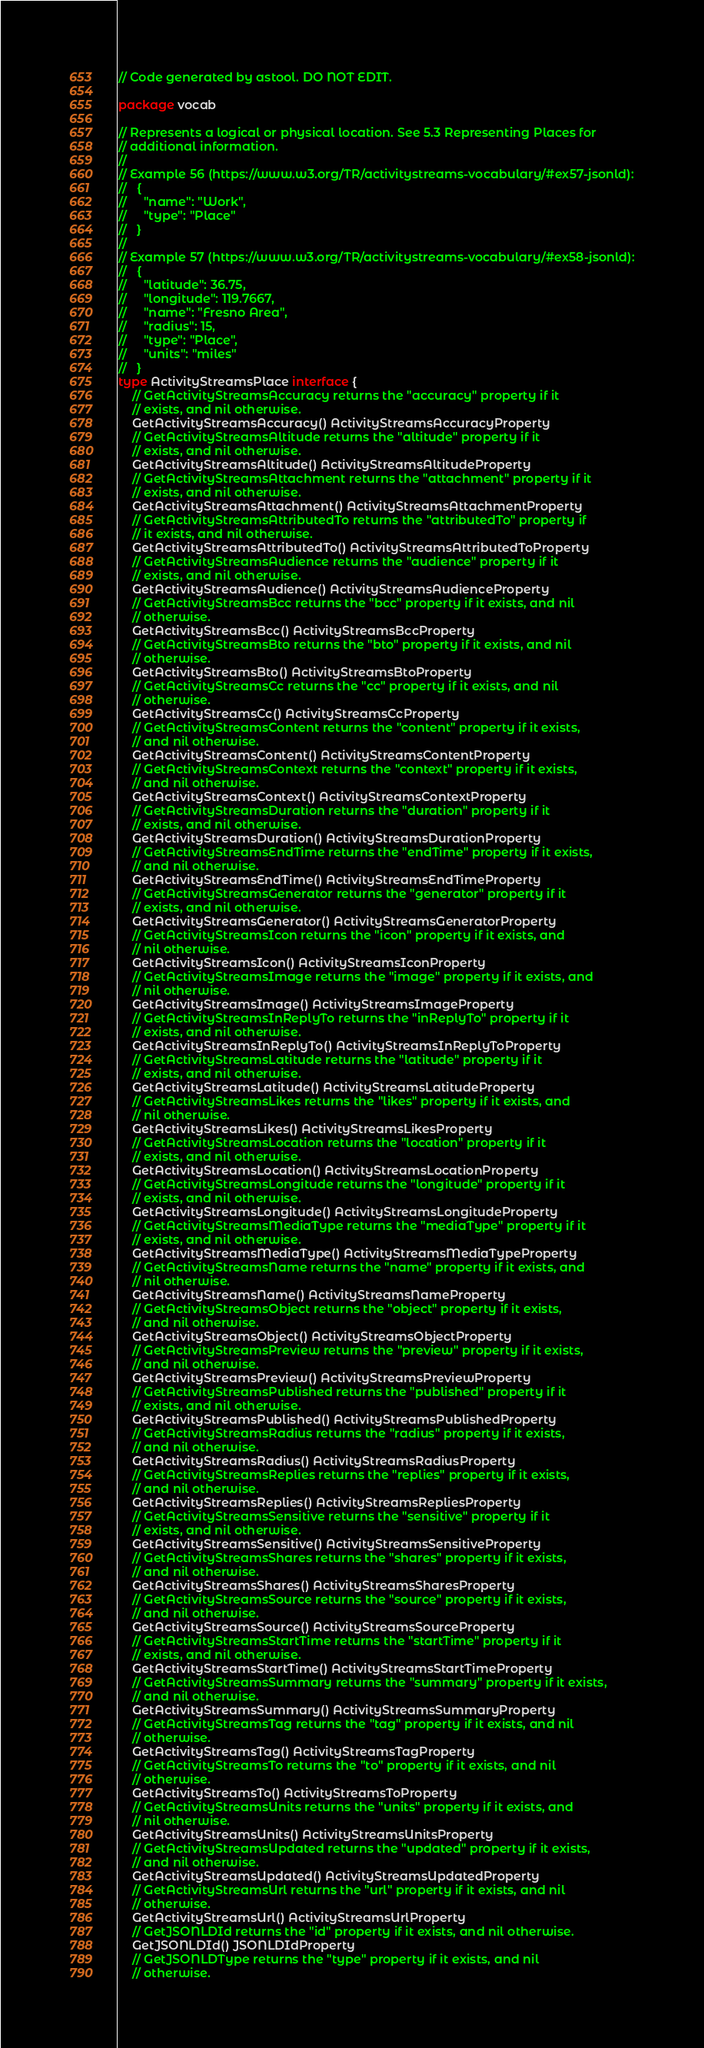Convert code to text. <code><loc_0><loc_0><loc_500><loc_500><_Go_>// Code generated by astool. DO NOT EDIT.

package vocab

// Represents a logical or physical location. See 5.3 Representing Places for
// additional information.
//
// Example 56 (https://www.w3.org/TR/activitystreams-vocabulary/#ex57-jsonld):
//   {
//     "name": "Work",
//     "type": "Place"
//   }
//
// Example 57 (https://www.w3.org/TR/activitystreams-vocabulary/#ex58-jsonld):
//   {
//     "latitude": 36.75,
//     "longitude": 119.7667,
//     "name": "Fresno Area",
//     "radius": 15,
//     "type": "Place",
//     "units": "miles"
//   }
type ActivityStreamsPlace interface {
	// GetActivityStreamsAccuracy returns the "accuracy" property if it
	// exists, and nil otherwise.
	GetActivityStreamsAccuracy() ActivityStreamsAccuracyProperty
	// GetActivityStreamsAltitude returns the "altitude" property if it
	// exists, and nil otherwise.
	GetActivityStreamsAltitude() ActivityStreamsAltitudeProperty
	// GetActivityStreamsAttachment returns the "attachment" property if it
	// exists, and nil otherwise.
	GetActivityStreamsAttachment() ActivityStreamsAttachmentProperty
	// GetActivityStreamsAttributedTo returns the "attributedTo" property if
	// it exists, and nil otherwise.
	GetActivityStreamsAttributedTo() ActivityStreamsAttributedToProperty
	// GetActivityStreamsAudience returns the "audience" property if it
	// exists, and nil otherwise.
	GetActivityStreamsAudience() ActivityStreamsAudienceProperty
	// GetActivityStreamsBcc returns the "bcc" property if it exists, and nil
	// otherwise.
	GetActivityStreamsBcc() ActivityStreamsBccProperty
	// GetActivityStreamsBto returns the "bto" property if it exists, and nil
	// otherwise.
	GetActivityStreamsBto() ActivityStreamsBtoProperty
	// GetActivityStreamsCc returns the "cc" property if it exists, and nil
	// otherwise.
	GetActivityStreamsCc() ActivityStreamsCcProperty
	// GetActivityStreamsContent returns the "content" property if it exists,
	// and nil otherwise.
	GetActivityStreamsContent() ActivityStreamsContentProperty
	// GetActivityStreamsContext returns the "context" property if it exists,
	// and nil otherwise.
	GetActivityStreamsContext() ActivityStreamsContextProperty
	// GetActivityStreamsDuration returns the "duration" property if it
	// exists, and nil otherwise.
	GetActivityStreamsDuration() ActivityStreamsDurationProperty
	// GetActivityStreamsEndTime returns the "endTime" property if it exists,
	// and nil otherwise.
	GetActivityStreamsEndTime() ActivityStreamsEndTimeProperty
	// GetActivityStreamsGenerator returns the "generator" property if it
	// exists, and nil otherwise.
	GetActivityStreamsGenerator() ActivityStreamsGeneratorProperty
	// GetActivityStreamsIcon returns the "icon" property if it exists, and
	// nil otherwise.
	GetActivityStreamsIcon() ActivityStreamsIconProperty
	// GetActivityStreamsImage returns the "image" property if it exists, and
	// nil otherwise.
	GetActivityStreamsImage() ActivityStreamsImageProperty
	// GetActivityStreamsInReplyTo returns the "inReplyTo" property if it
	// exists, and nil otherwise.
	GetActivityStreamsInReplyTo() ActivityStreamsInReplyToProperty
	// GetActivityStreamsLatitude returns the "latitude" property if it
	// exists, and nil otherwise.
	GetActivityStreamsLatitude() ActivityStreamsLatitudeProperty
	// GetActivityStreamsLikes returns the "likes" property if it exists, and
	// nil otherwise.
	GetActivityStreamsLikes() ActivityStreamsLikesProperty
	// GetActivityStreamsLocation returns the "location" property if it
	// exists, and nil otherwise.
	GetActivityStreamsLocation() ActivityStreamsLocationProperty
	// GetActivityStreamsLongitude returns the "longitude" property if it
	// exists, and nil otherwise.
	GetActivityStreamsLongitude() ActivityStreamsLongitudeProperty
	// GetActivityStreamsMediaType returns the "mediaType" property if it
	// exists, and nil otherwise.
	GetActivityStreamsMediaType() ActivityStreamsMediaTypeProperty
	// GetActivityStreamsName returns the "name" property if it exists, and
	// nil otherwise.
	GetActivityStreamsName() ActivityStreamsNameProperty
	// GetActivityStreamsObject returns the "object" property if it exists,
	// and nil otherwise.
	GetActivityStreamsObject() ActivityStreamsObjectProperty
	// GetActivityStreamsPreview returns the "preview" property if it exists,
	// and nil otherwise.
	GetActivityStreamsPreview() ActivityStreamsPreviewProperty
	// GetActivityStreamsPublished returns the "published" property if it
	// exists, and nil otherwise.
	GetActivityStreamsPublished() ActivityStreamsPublishedProperty
	// GetActivityStreamsRadius returns the "radius" property if it exists,
	// and nil otherwise.
	GetActivityStreamsRadius() ActivityStreamsRadiusProperty
	// GetActivityStreamsReplies returns the "replies" property if it exists,
	// and nil otherwise.
	GetActivityStreamsReplies() ActivityStreamsRepliesProperty
	// GetActivityStreamsSensitive returns the "sensitive" property if it
	// exists, and nil otherwise.
	GetActivityStreamsSensitive() ActivityStreamsSensitiveProperty
	// GetActivityStreamsShares returns the "shares" property if it exists,
	// and nil otherwise.
	GetActivityStreamsShares() ActivityStreamsSharesProperty
	// GetActivityStreamsSource returns the "source" property if it exists,
	// and nil otherwise.
	GetActivityStreamsSource() ActivityStreamsSourceProperty
	// GetActivityStreamsStartTime returns the "startTime" property if it
	// exists, and nil otherwise.
	GetActivityStreamsStartTime() ActivityStreamsStartTimeProperty
	// GetActivityStreamsSummary returns the "summary" property if it exists,
	// and nil otherwise.
	GetActivityStreamsSummary() ActivityStreamsSummaryProperty
	// GetActivityStreamsTag returns the "tag" property if it exists, and nil
	// otherwise.
	GetActivityStreamsTag() ActivityStreamsTagProperty
	// GetActivityStreamsTo returns the "to" property if it exists, and nil
	// otherwise.
	GetActivityStreamsTo() ActivityStreamsToProperty
	// GetActivityStreamsUnits returns the "units" property if it exists, and
	// nil otherwise.
	GetActivityStreamsUnits() ActivityStreamsUnitsProperty
	// GetActivityStreamsUpdated returns the "updated" property if it exists,
	// and nil otherwise.
	GetActivityStreamsUpdated() ActivityStreamsUpdatedProperty
	// GetActivityStreamsUrl returns the "url" property if it exists, and nil
	// otherwise.
	GetActivityStreamsUrl() ActivityStreamsUrlProperty
	// GetJSONLDId returns the "id" property if it exists, and nil otherwise.
	GetJSONLDId() JSONLDIdProperty
	// GetJSONLDType returns the "type" property if it exists, and nil
	// otherwise.</code> 